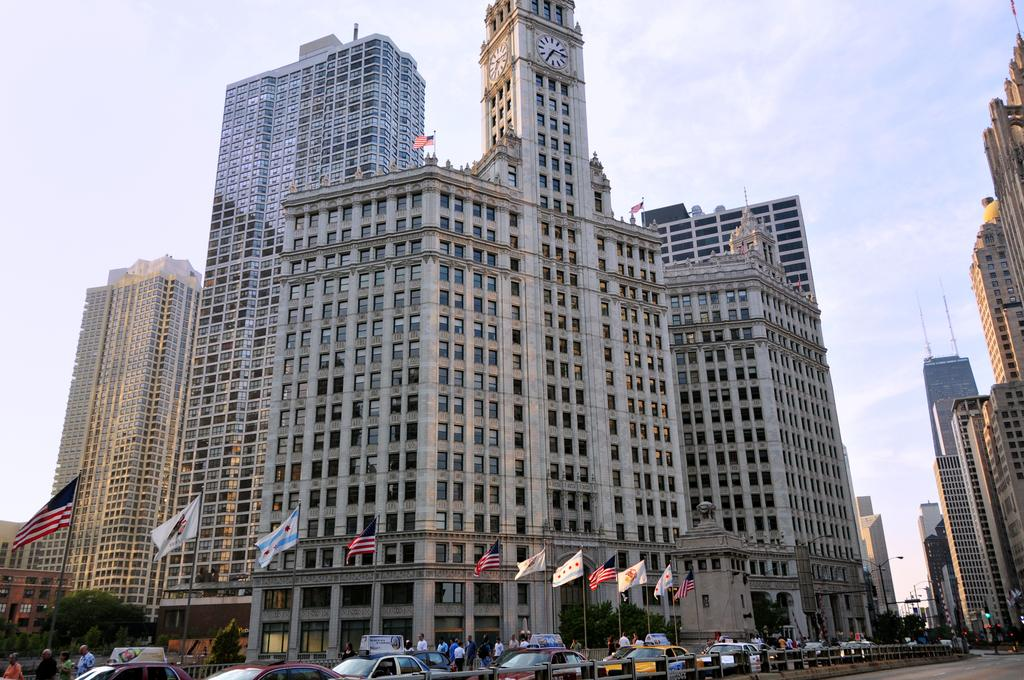What types of subjects can be seen in the image? There are people, vehicles, flags, boards, lights, poles, trees, and buildings in the image. Can you describe the environment in the image? The image features a mix of natural elements like trees and man-made structures such as buildings, vehicles, and flags. What is visible in the background of the image? The sky is visible in the background of the image. How many types of objects are present in the image? There are nine types of objects present in the image: people, vehicles, flags, boards, lights, poles, trees, and buildings. What effect does the slip have on the people in the image? There is no mention of a slip in the image, so it's not possible to determine any effect on the people. 